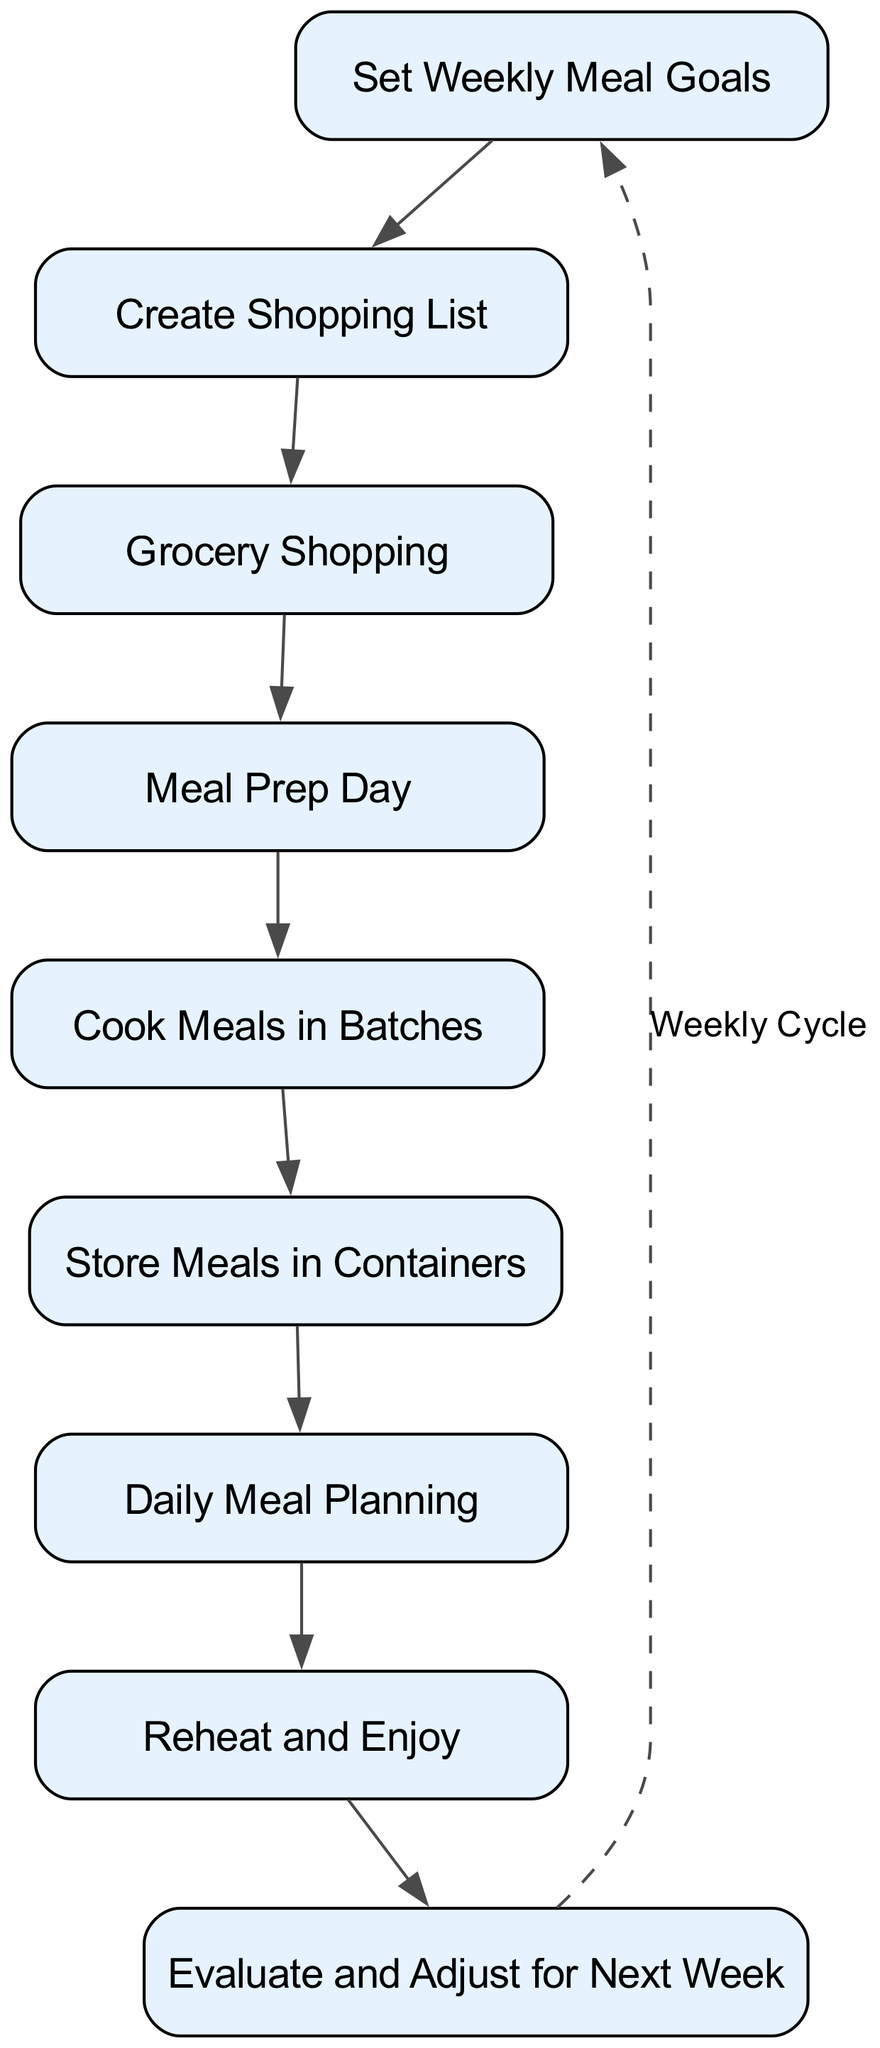What is the first step in the meal preparation workflow? The first step in the workflow is "Set Weekly Meal Goals", as shown at the top of the flow chart.
Answer: Set Weekly Meal Goals How many total process nodes are in the diagram? By counting all distinct process nodes in the diagram, there are a total of nine nodes listed.
Answer: 9 What follows after "Grocery Shopping"? The next step after "Grocery Shopping" is "Meal Prep Day", which is indicated by the direct edge leading from one to the next in the flow.
Answer: Meal Prep Day What is the last step in the meal preparation workflow? The last step before looping back is "Evaluate and Adjust for Next Week", which is the final node in the flow chart.
Answer: Evaluate and Adjust for Next Week Which step has a dashed edge connected to it, and what does that signify? The step "Evaluate and Adjust for Next Week" has a dashed edge connecting back to "Set Weekly Meal Goals", signifying a weekly cycle or repetition in the workflow.
Answer: Evaluate and Adjust for Next Week What is the relationship between "Cook Meals in Batches" and "Store Meals in Containers"? "Cook Meals in Batches" directly leads to "Store Meals in Containers", meaning you first cook in batches, then proceed to store them.
Answer: Direct relationship What step comes immediately after "Daily Meal Planning"? After "Daily Meal Planning", the next step is "Reheat and Enjoy", as shown by the sequential flow in the diagram.
Answer: Reheat and Enjoy What does the dashed line represent in the flowchart? The dashed line represents a looping connection indicating that the process is cyclical and starts over with set weekly goals after evaluating the previous week.
Answer: Weekly Cycle 